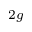Convert formula to latex. <formula><loc_0><loc_0><loc_500><loc_500>_ { 2 g }</formula> 